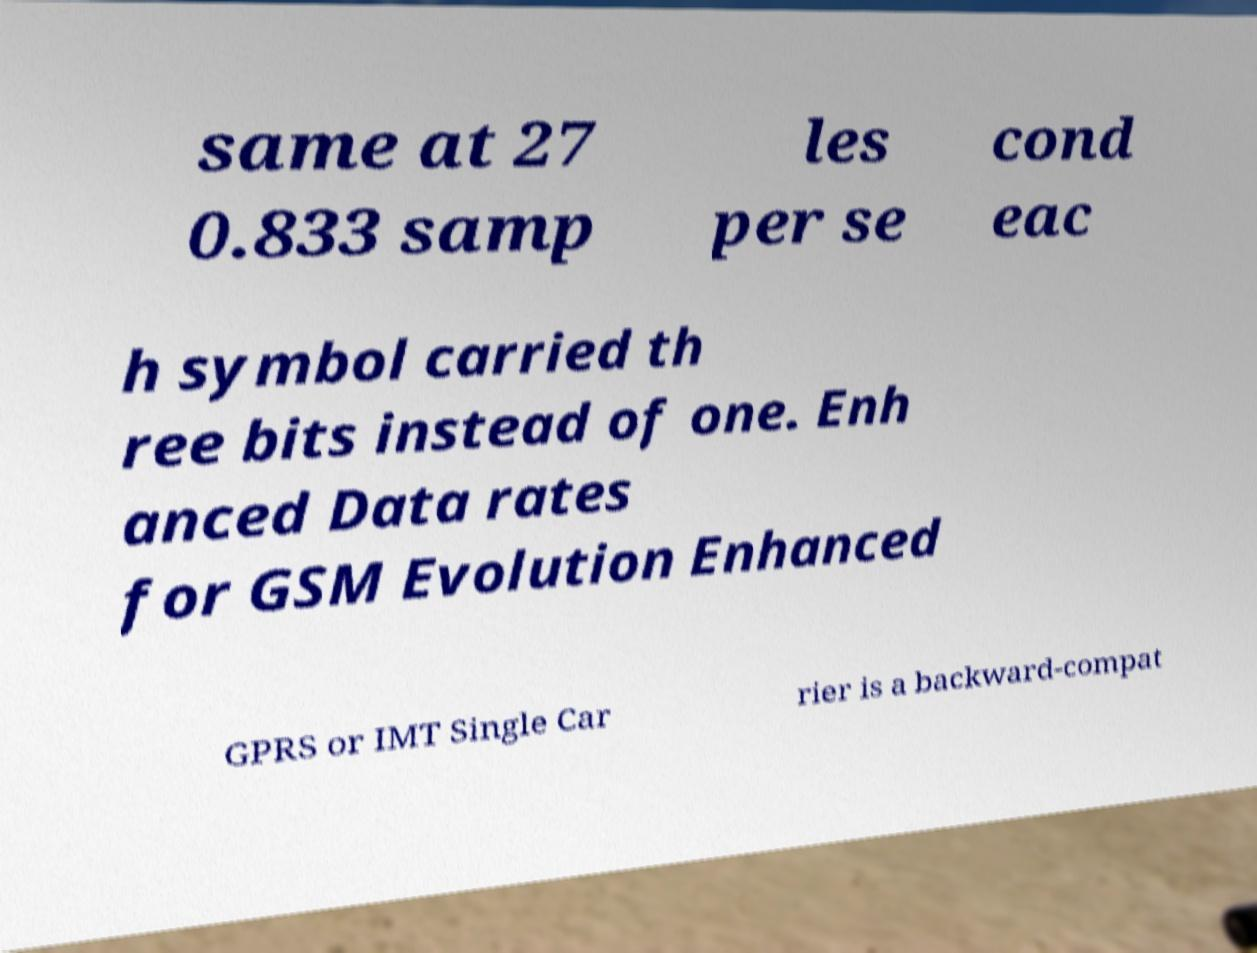There's text embedded in this image that I need extracted. Can you transcribe it verbatim? same at 27 0.833 samp les per se cond eac h symbol carried th ree bits instead of one. Enh anced Data rates for GSM Evolution Enhanced GPRS or IMT Single Car rier is a backward-compat 